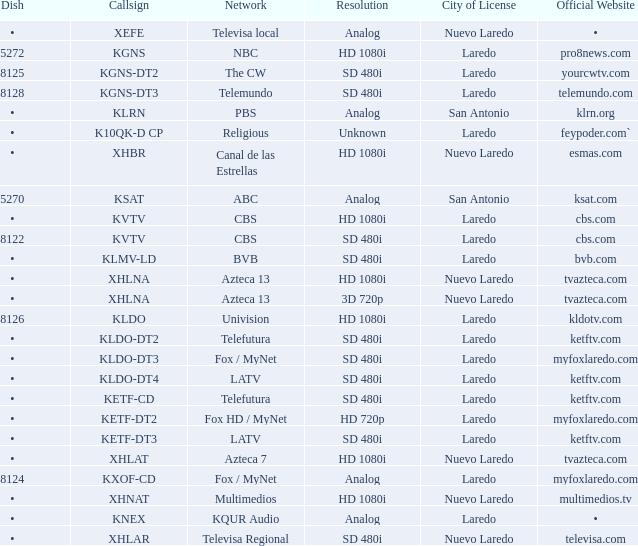Determine the food for 480i sd resolution compatibility and bvb network. •. 